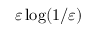Convert formula to latex. <formula><loc_0><loc_0><loc_500><loc_500>\varepsilon \log ( 1 / \varepsilon )</formula> 